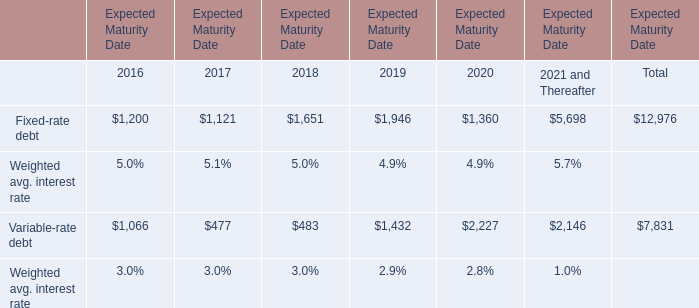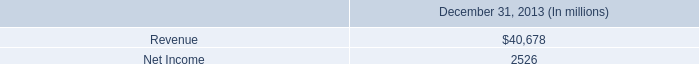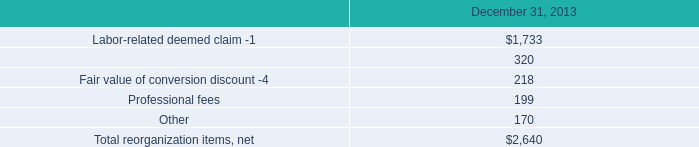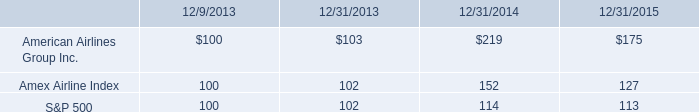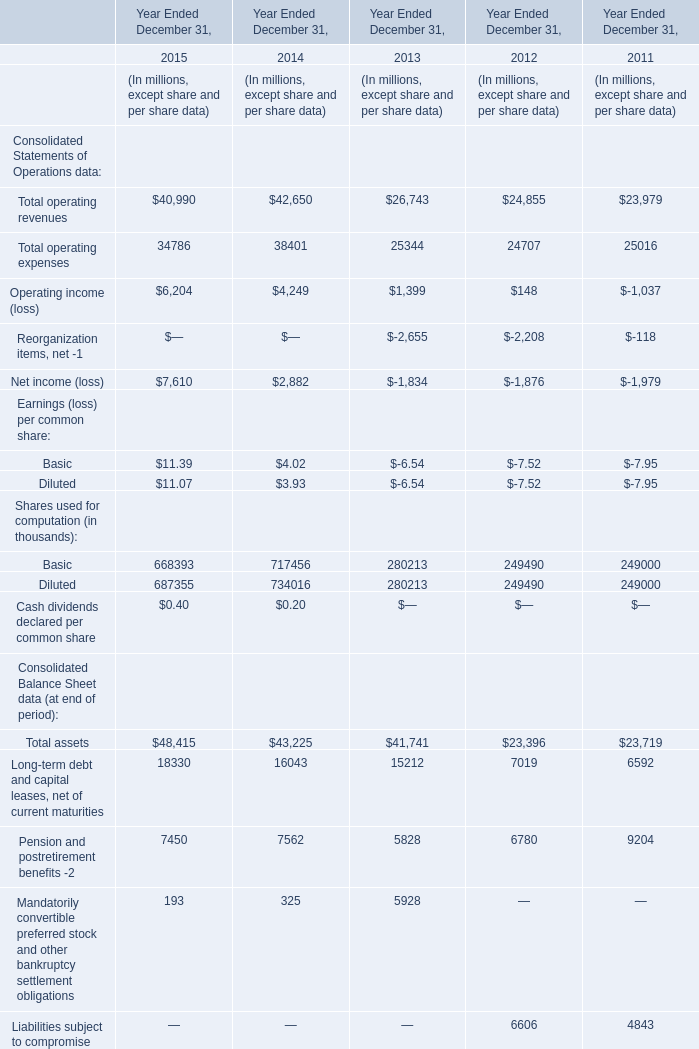In what year is Total operating revenues greater than 42000? 
Answer: 2014. 